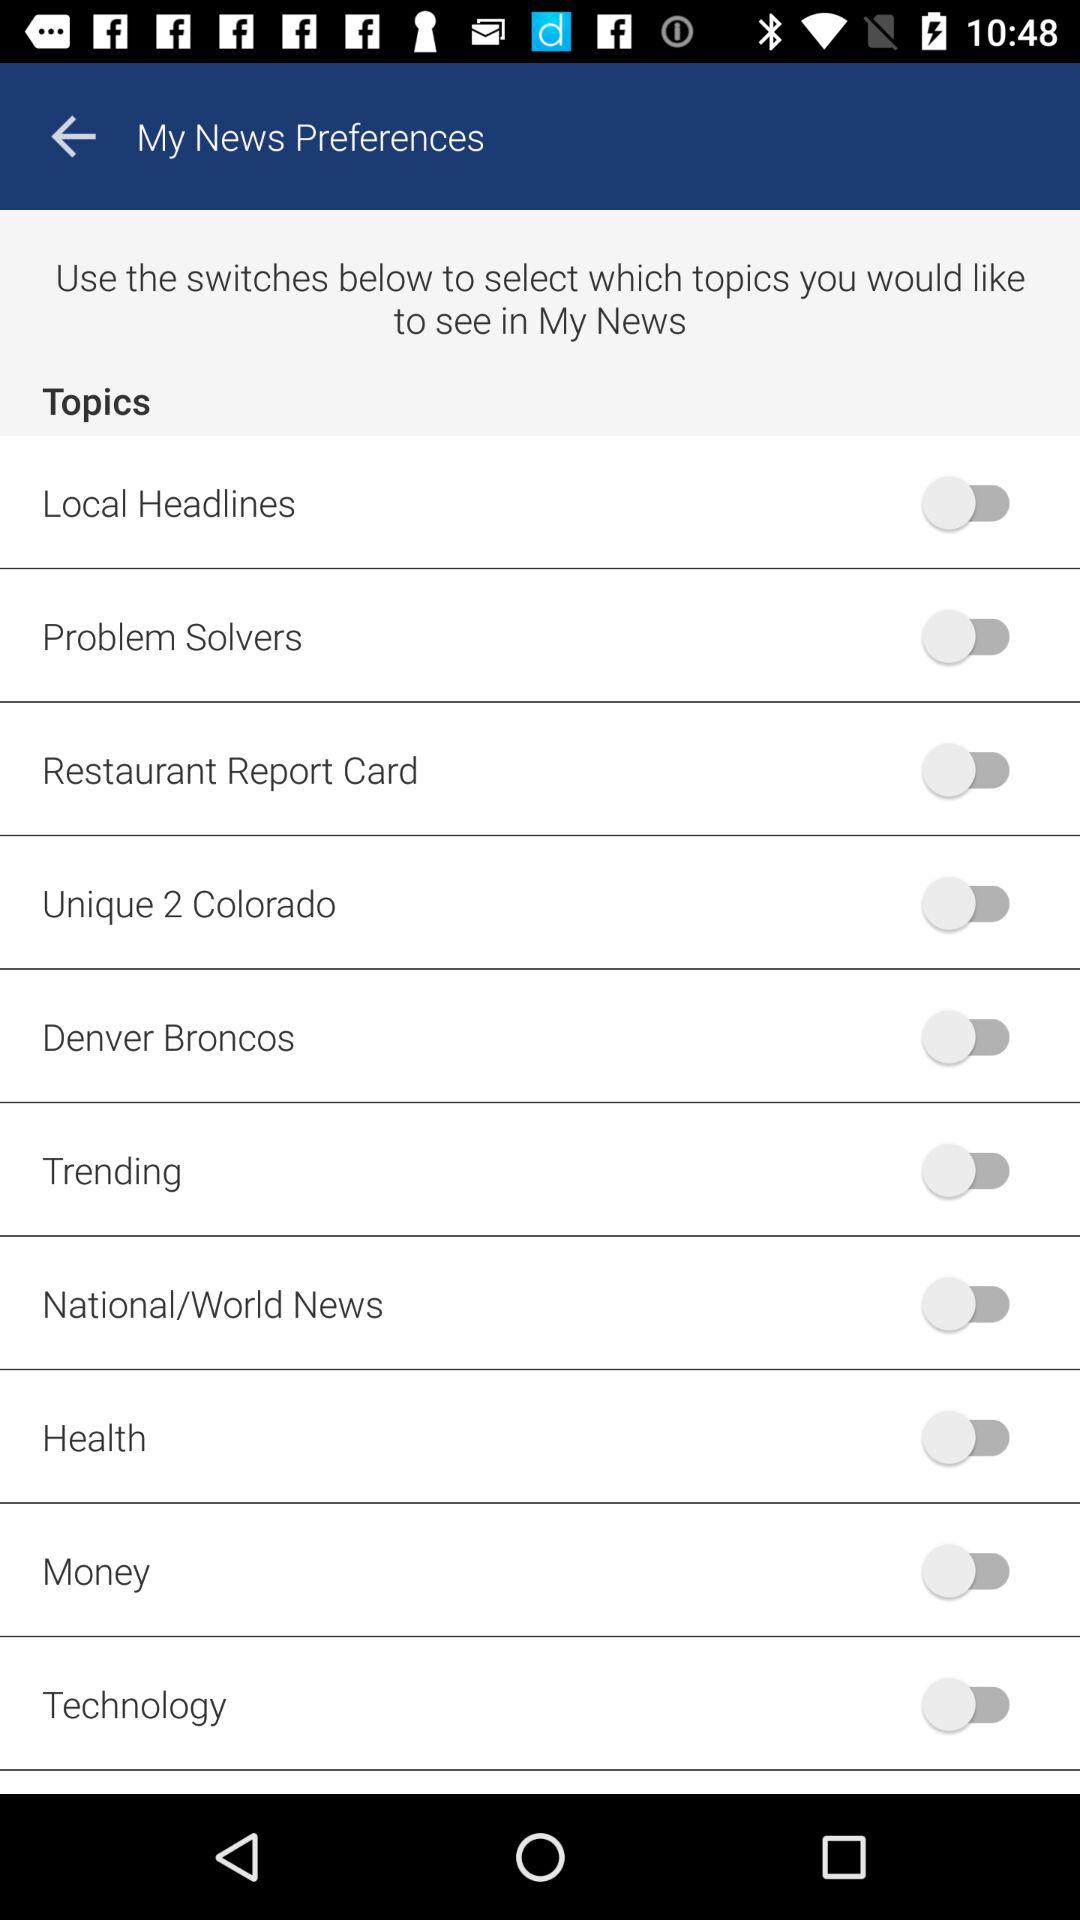What is the status of "Local Headlines"? The status of "Local Headlines" is "off". 